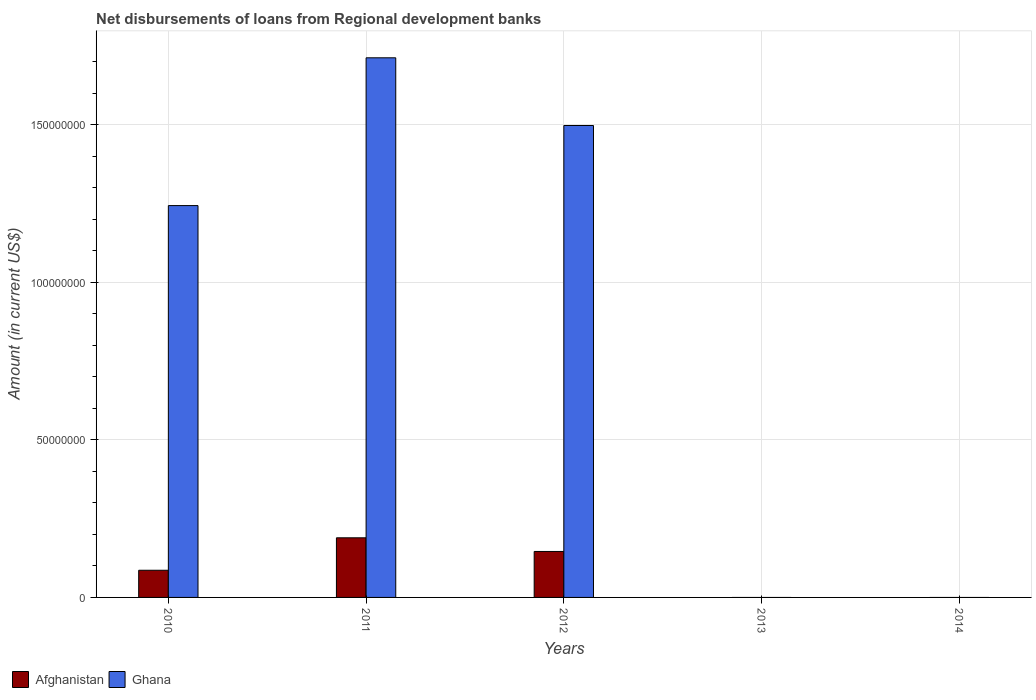How many different coloured bars are there?
Provide a succinct answer. 2. Are the number of bars on each tick of the X-axis equal?
Make the answer very short. No. How many bars are there on the 2nd tick from the right?
Provide a short and direct response. 0. What is the label of the 2nd group of bars from the left?
Provide a short and direct response. 2011. In how many cases, is the number of bars for a given year not equal to the number of legend labels?
Ensure brevity in your answer.  2. Across all years, what is the maximum amount of disbursements of loans from regional development banks in Afghanistan?
Your response must be concise. 1.89e+07. Across all years, what is the minimum amount of disbursements of loans from regional development banks in Ghana?
Keep it short and to the point. 0. What is the total amount of disbursements of loans from regional development banks in Afghanistan in the graph?
Provide a short and direct response. 4.21e+07. What is the difference between the amount of disbursements of loans from regional development banks in Afghanistan in 2014 and the amount of disbursements of loans from regional development banks in Ghana in 2012?
Offer a terse response. -1.50e+08. What is the average amount of disbursements of loans from regional development banks in Ghana per year?
Your answer should be compact. 8.91e+07. In the year 2012, what is the difference between the amount of disbursements of loans from regional development banks in Ghana and amount of disbursements of loans from regional development banks in Afghanistan?
Your answer should be very brief. 1.35e+08. In how many years, is the amount of disbursements of loans from regional development banks in Ghana greater than 100000000 US$?
Ensure brevity in your answer.  3. What is the ratio of the amount of disbursements of loans from regional development banks in Afghanistan in 2011 to that in 2012?
Keep it short and to the point. 1.3. What is the difference between the highest and the second highest amount of disbursements of loans from regional development banks in Afghanistan?
Your answer should be compact. 4.33e+06. What is the difference between the highest and the lowest amount of disbursements of loans from regional development banks in Afghanistan?
Your answer should be very brief. 1.89e+07. How many bars are there?
Ensure brevity in your answer.  6. How many years are there in the graph?
Your answer should be compact. 5. What is the difference between two consecutive major ticks on the Y-axis?
Keep it short and to the point. 5.00e+07. Does the graph contain grids?
Give a very brief answer. Yes. How many legend labels are there?
Your answer should be very brief. 2. How are the legend labels stacked?
Offer a very short reply. Horizontal. What is the title of the graph?
Give a very brief answer. Net disbursements of loans from Regional development banks. What is the label or title of the X-axis?
Provide a short and direct response. Years. What is the Amount (in current US$) of Afghanistan in 2010?
Your answer should be compact. 8.62e+06. What is the Amount (in current US$) of Ghana in 2010?
Make the answer very short. 1.24e+08. What is the Amount (in current US$) in Afghanistan in 2011?
Offer a very short reply. 1.89e+07. What is the Amount (in current US$) in Ghana in 2011?
Your answer should be very brief. 1.71e+08. What is the Amount (in current US$) in Afghanistan in 2012?
Your response must be concise. 1.46e+07. What is the Amount (in current US$) of Ghana in 2012?
Your response must be concise. 1.50e+08. Across all years, what is the maximum Amount (in current US$) of Afghanistan?
Ensure brevity in your answer.  1.89e+07. Across all years, what is the maximum Amount (in current US$) in Ghana?
Keep it short and to the point. 1.71e+08. What is the total Amount (in current US$) of Afghanistan in the graph?
Your answer should be very brief. 4.21e+07. What is the total Amount (in current US$) of Ghana in the graph?
Your answer should be compact. 4.45e+08. What is the difference between the Amount (in current US$) of Afghanistan in 2010 and that in 2011?
Keep it short and to the point. -1.03e+07. What is the difference between the Amount (in current US$) of Ghana in 2010 and that in 2011?
Give a very brief answer. -4.69e+07. What is the difference between the Amount (in current US$) in Afghanistan in 2010 and that in 2012?
Your answer should be compact. -5.97e+06. What is the difference between the Amount (in current US$) of Ghana in 2010 and that in 2012?
Give a very brief answer. -2.54e+07. What is the difference between the Amount (in current US$) in Afghanistan in 2011 and that in 2012?
Provide a short and direct response. 4.33e+06. What is the difference between the Amount (in current US$) in Ghana in 2011 and that in 2012?
Provide a succinct answer. 2.15e+07. What is the difference between the Amount (in current US$) of Afghanistan in 2010 and the Amount (in current US$) of Ghana in 2011?
Offer a terse response. -1.63e+08. What is the difference between the Amount (in current US$) in Afghanistan in 2010 and the Amount (in current US$) in Ghana in 2012?
Keep it short and to the point. -1.41e+08. What is the difference between the Amount (in current US$) in Afghanistan in 2011 and the Amount (in current US$) in Ghana in 2012?
Your answer should be very brief. -1.31e+08. What is the average Amount (in current US$) in Afghanistan per year?
Keep it short and to the point. 8.43e+06. What is the average Amount (in current US$) in Ghana per year?
Give a very brief answer. 8.91e+07. In the year 2010, what is the difference between the Amount (in current US$) in Afghanistan and Amount (in current US$) in Ghana?
Offer a very short reply. -1.16e+08. In the year 2011, what is the difference between the Amount (in current US$) in Afghanistan and Amount (in current US$) in Ghana?
Give a very brief answer. -1.52e+08. In the year 2012, what is the difference between the Amount (in current US$) of Afghanistan and Amount (in current US$) of Ghana?
Provide a short and direct response. -1.35e+08. What is the ratio of the Amount (in current US$) of Afghanistan in 2010 to that in 2011?
Give a very brief answer. 0.46. What is the ratio of the Amount (in current US$) of Ghana in 2010 to that in 2011?
Offer a very short reply. 0.73. What is the ratio of the Amount (in current US$) of Afghanistan in 2010 to that in 2012?
Provide a short and direct response. 0.59. What is the ratio of the Amount (in current US$) of Ghana in 2010 to that in 2012?
Give a very brief answer. 0.83. What is the ratio of the Amount (in current US$) in Afghanistan in 2011 to that in 2012?
Ensure brevity in your answer.  1.3. What is the ratio of the Amount (in current US$) of Ghana in 2011 to that in 2012?
Your answer should be compact. 1.14. What is the difference between the highest and the second highest Amount (in current US$) of Afghanistan?
Your response must be concise. 4.33e+06. What is the difference between the highest and the second highest Amount (in current US$) of Ghana?
Your response must be concise. 2.15e+07. What is the difference between the highest and the lowest Amount (in current US$) of Afghanistan?
Provide a short and direct response. 1.89e+07. What is the difference between the highest and the lowest Amount (in current US$) of Ghana?
Your answer should be very brief. 1.71e+08. 